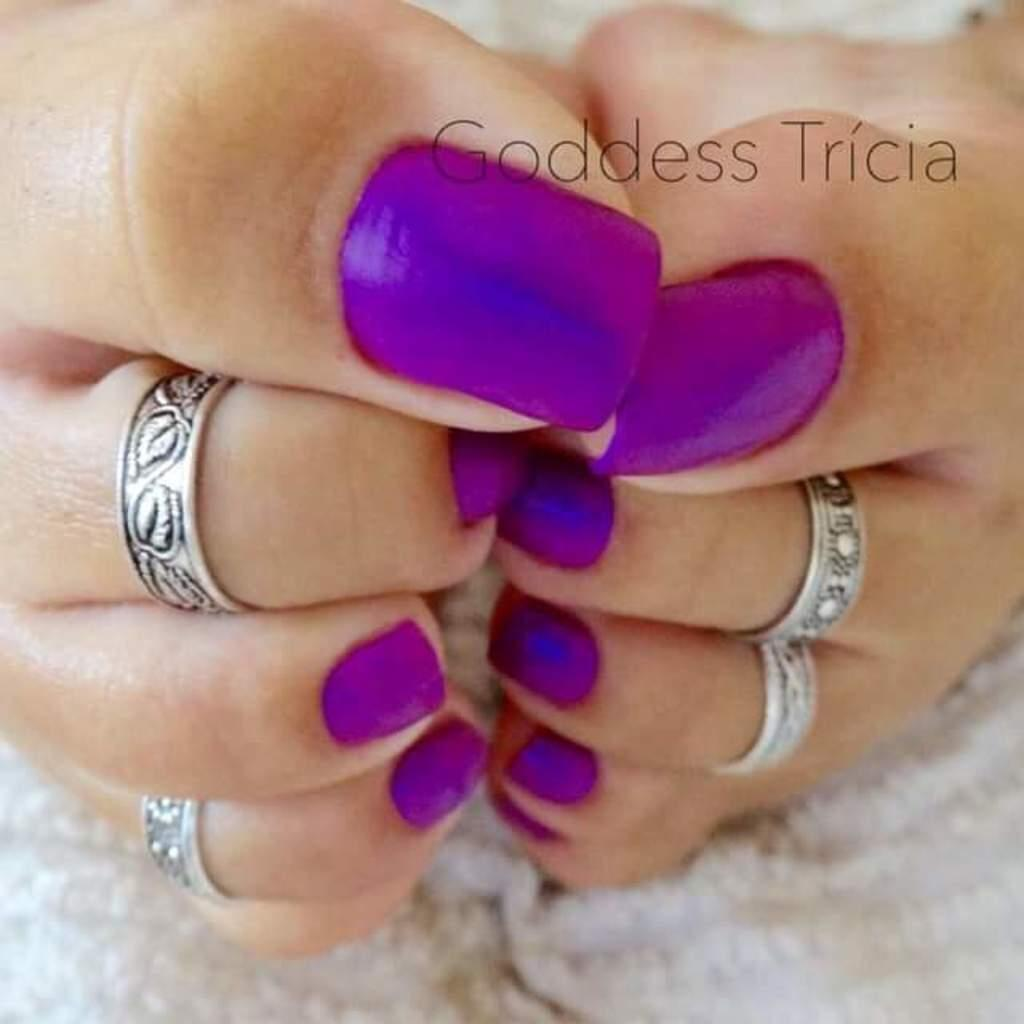What body part is visible in the image? Human feet are visible in the image. What type of accessory is present on the feet? Toe rings are present on the feet. How are the nails on the feet decorated? The nails on the feet are colorful. What is located at the bottom of the image? There is a white cloth at the bottom of the image. What can be seen at the top of the image? A watermark is present at the top of the image. What type of alley can be seen in the image? There is no alley present in the image; it features human feet with toe rings and colorful nails. 